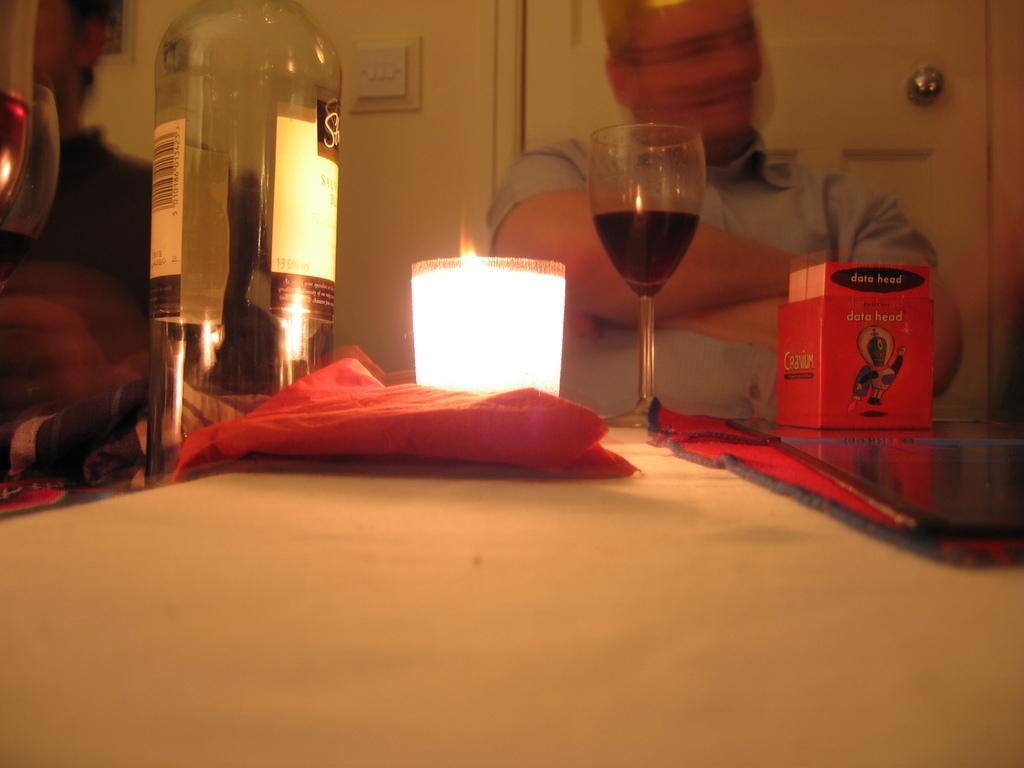In one or two sentences, can you explain what this image depicts? On the background we can see wall, switch board and a door. Here we can see men sitting on chairs in front of a table and on the table we can see box, cloth, glass with drink in it and a bottle. 